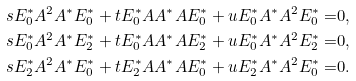<formula> <loc_0><loc_0><loc_500><loc_500>s E _ { 0 } ^ { * } A ^ { 2 } A ^ { * } E _ { 0 } ^ { * } + t E _ { 0 } ^ { * } A A ^ { * } A E _ { 0 } ^ { * } + u E _ { 0 } ^ { * } A ^ { * } A ^ { 2 } E _ { 0 } ^ { * } = & 0 , \\ s E _ { 0 } ^ { * } A ^ { 2 } A ^ { * } E _ { 2 } ^ { * } + t E _ { 0 } ^ { * } A A ^ { * } A E _ { 2 } ^ { * } + u E _ { 0 } ^ { * } A ^ { * } A ^ { 2 } E _ { 2 } ^ { * } = & 0 , \\ s E _ { 2 } ^ { * } A ^ { 2 } A ^ { * } E _ { 0 } ^ { * } + t E _ { 2 } ^ { * } A A ^ { * } A E _ { 0 } ^ { * } + u E _ { 2 } ^ { * } A ^ { * } A ^ { 2 } E _ { 0 } ^ { * } = & 0 .</formula> 